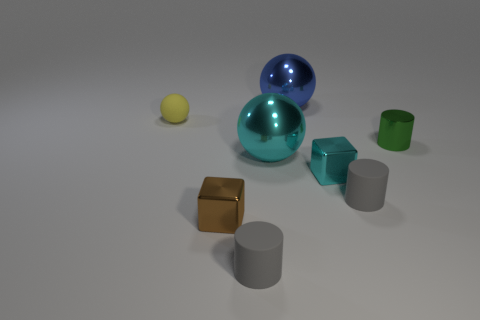Are there more cylindrical shapes or spherical shapes in the image? There is a higher count of cylindrical shapes in the image, totaling three, compared to two spherical shapes. 